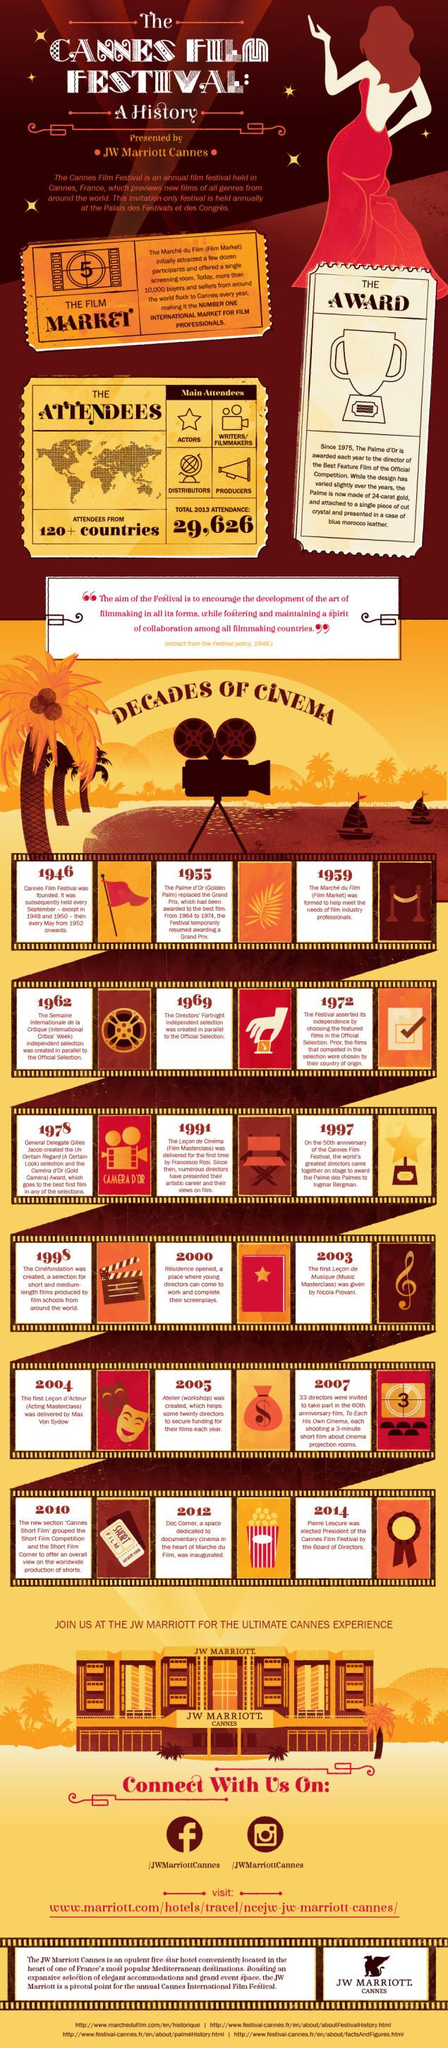Point out several critical features in this image. In 1955, the Grand Prix title was temporarily replaced by the Golden Palm title. The first non-dependent selection committee, which corresponds to the official committee formed in 1969, was established in 1969. The initial masterclass in Music was taken in 2003. 